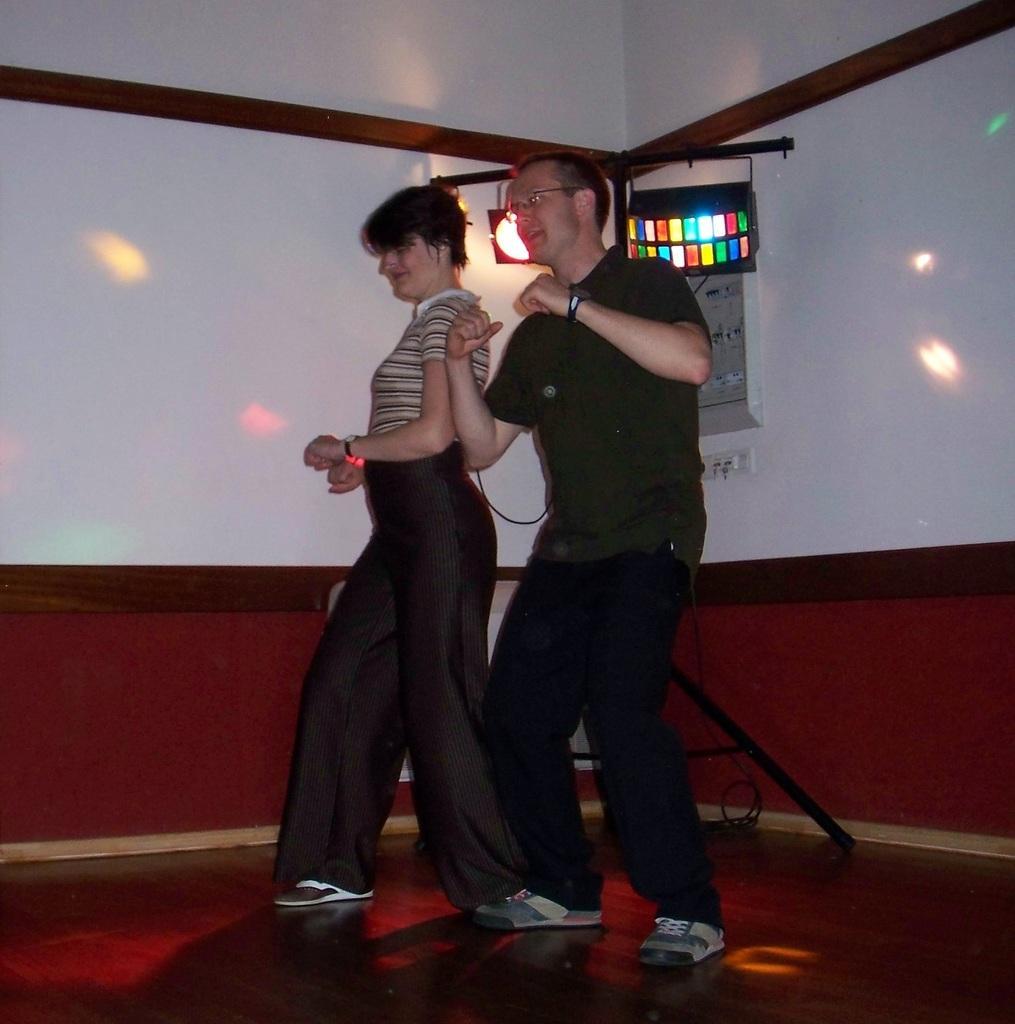Could you give a brief overview of what you see in this image? In this picture, looks like a man and a woman dancing and I can see couple of lights to the stand and a frame on the wall. 